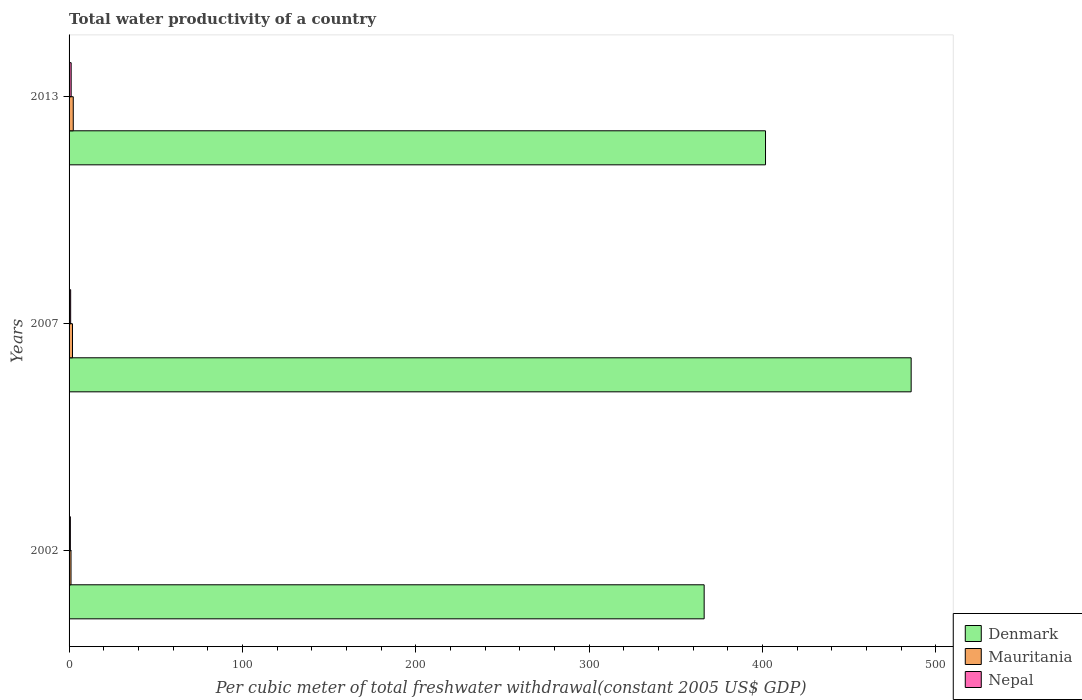How many different coloured bars are there?
Keep it short and to the point. 3. How many groups of bars are there?
Make the answer very short. 3. Are the number of bars on each tick of the Y-axis equal?
Offer a very short reply. Yes. How many bars are there on the 3rd tick from the bottom?
Your answer should be very brief. 3. What is the label of the 2nd group of bars from the top?
Offer a terse response. 2007. What is the total water productivity in Mauritania in 2007?
Your answer should be very brief. 1.98. Across all years, what is the maximum total water productivity in Mauritania?
Ensure brevity in your answer.  2.42. Across all years, what is the minimum total water productivity in Mauritania?
Keep it short and to the point. 1.12. In which year was the total water productivity in Nepal maximum?
Offer a terse response. 2013. In which year was the total water productivity in Nepal minimum?
Ensure brevity in your answer.  2002. What is the total total water productivity in Nepal in the graph?
Keep it short and to the point. 2.87. What is the difference between the total water productivity in Mauritania in 2002 and that in 2013?
Your answer should be very brief. -1.31. What is the difference between the total water productivity in Denmark in 2013 and the total water productivity in Nepal in 2007?
Keep it short and to the point. 400.81. What is the average total water productivity in Mauritania per year?
Provide a succinct answer. 1.84. In the year 2013, what is the difference between the total water productivity in Denmark and total water productivity in Mauritania?
Provide a short and direct response. 399.3. In how many years, is the total water productivity in Mauritania greater than 100 US$?
Keep it short and to the point. 0. What is the ratio of the total water productivity in Denmark in 2007 to that in 2013?
Your answer should be very brief. 1.21. What is the difference between the highest and the second highest total water productivity in Denmark?
Provide a short and direct response. 84.01. What is the difference between the highest and the lowest total water productivity in Nepal?
Offer a terse response. 0.45. What does the 2nd bar from the top in 2002 represents?
Your answer should be compact. Mauritania. What does the 3rd bar from the bottom in 2007 represents?
Your answer should be very brief. Nepal. Is it the case that in every year, the sum of the total water productivity in Nepal and total water productivity in Denmark is greater than the total water productivity in Mauritania?
Ensure brevity in your answer.  Yes. How many bars are there?
Keep it short and to the point. 9. Are all the bars in the graph horizontal?
Make the answer very short. Yes. How many years are there in the graph?
Offer a very short reply. 3. Are the values on the major ticks of X-axis written in scientific E-notation?
Offer a very short reply. No. Does the graph contain grids?
Your answer should be very brief. No. Where does the legend appear in the graph?
Give a very brief answer. Bottom right. How many legend labels are there?
Make the answer very short. 3. How are the legend labels stacked?
Keep it short and to the point. Vertical. What is the title of the graph?
Your answer should be very brief. Total water productivity of a country. What is the label or title of the X-axis?
Make the answer very short. Per cubic meter of total freshwater withdrawal(constant 2005 US$ GDP). What is the Per cubic meter of total freshwater withdrawal(constant 2005 US$ GDP) in Denmark in 2002?
Your answer should be very brief. 366.34. What is the Per cubic meter of total freshwater withdrawal(constant 2005 US$ GDP) in Mauritania in 2002?
Provide a succinct answer. 1.12. What is the Per cubic meter of total freshwater withdrawal(constant 2005 US$ GDP) in Nepal in 2002?
Offer a terse response. 0.76. What is the Per cubic meter of total freshwater withdrawal(constant 2005 US$ GDP) in Denmark in 2007?
Ensure brevity in your answer.  485.73. What is the Per cubic meter of total freshwater withdrawal(constant 2005 US$ GDP) in Mauritania in 2007?
Provide a succinct answer. 1.98. What is the Per cubic meter of total freshwater withdrawal(constant 2005 US$ GDP) of Nepal in 2007?
Provide a succinct answer. 0.92. What is the Per cubic meter of total freshwater withdrawal(constant 2005 US$ GDP) in Denmark in 2013?
Offer a very short reply. 401.72. What is the Per cubic meter of total freshwater withdrawal(constant 2005 US$ GDP) of Mauritania in 2013?
Keep it short and to the point. 2.42. What is the Per cubic meter of total freshwater withdrawal(constant 2005 US$ GDP) of Nepal in 2013?
Keep it short and to the point. 1.2. Across all years, what is the maximum Per cubic meter of total freshwater withdrawal(constant 2005 US$ GDP) in Denmark?
Provide a short and direct response. 485.73. Across all years, what is the maximum Per cubic meter of total freshwater withdrawal(constant 2005 US$ GDP) of Mauritania?
Offer a terse response. 2.42. Across all years, what is the maximum Per cubic meter of total freshwater withdrawal(constant 2005 US$ GDP) in Nepal?
Offer a terse response. 1.2. Across all years, what is the minimum Per cubic meter of total freshwater withdrawal(constant 2005 US$ GDP) in Denmark?
Give a very brief answer. 366.34. Across all years, what is the minimum Per cubic meter of total freshwater withdrawal(constant 2005 US$ GDP) in Mauritania?
Provide a succinct answer. 1.12. Across all years, what is the minimum Per cubic meter of total freshwater withdrawal(constant 2005 US$ GDP) in Nepal?
Ensure brevity in your answer.  0.76. What is the total Per cubic meter of total freshwater withdrawal(constant 2005 US$ GDP) of Denmark in the graph?
Ensure brevity in your answer.  1253.79. What is the total Per cubic meter of total freshwater withdrawal(constant 2005 US$ GDP) in Mauritania in the graph?
Your answer should be compact. 5.52. What is the total Per cubic meter of total freshwater withdrawal(constant 2005 US$ GDP) in Nepal in the graph?
Your response must be concise. 2.87. What is the difference between the Per cubic meter of total freshwater withdrawal(constant 2005 US$ GDP) of Denmark in 2002 and that in 2007?
Make the answer very short. -119.4. What is the difference between the Per cubic meter of total freshwater withdrawal(constant 2005 US$ GDP) in Mauritania in 2002 and that in 2007?
Your answer should be very brief. -0.86. What is the difference between the Per cubic meter of total freshwater withdrawal(constant 2005 US$ GDP) of Nepal in 2002 and that in 2007?
Ensure brevity in your answer.  -0.16. What is the difference between the Per cubic meter of total freshwater withdrawal(constant 2005 US$ GDP) in Denmark in 2002 and that in 2013?
Ensure brevity in your answer.  -35.39. What is the difference between the Per cubic meter of total freshwater withdrawal(constant 2005 US$ GDP) of Mauritania in 2002 and that in 2013?
Keep it short and to the point. -1.31. What is the difference between the Per cubic meter of total freshwater withdrawal(constant 2005 US$ GDP) of Nepal in 2002 and that in 2013?
Offer a very short reply. -0.45. What is the difference between the Per cubic meter of total freshwater withdrawal(constant 2005 US$ GDP) in Denmark in 2007 and that in 2013?
Make the answer very short. 84.01. What is the difference between the Per cubic meter of total freshwater withdrawal(constant 2005 US$ GDP) of Mauritania in 2007 and that in 2013?
Offer a terse response. -0.45. What is the difference between the Per cubic meter of total freshwater withdrawal(constant 2005 US$ GDP) of Nepal in 2007 and that in 2013?
Your answer should be compact. -0.29. What is the difference between the Per cubic meter of total freshwater withdrawal(constant 2005 US$ GDP) of Denmark in 2002 and the Per cubic meter of total freshwater withdrawal(constant 2005 US$ GDP) of Mauritania in 2007?
Provide a succinct answer. 364.36. What is the difference between the Per cubic meter of total freshwater withdrawal(constant 2005 US$ GDP) of Denmark in 2002 and the Per cubic meter of total freshwater withdrawal(constant 2005 US$ GDP) of Nepal in 2007?
Keep it short and to the point. 365.42. What is the difference between the Per cubic meter of total freshwater withdrawal(constant 2005 US$ GDP) of Mauritania in 2002 and the Per cubic meter of total freshwater withdrawal(constant 2005 US$ GDP) of Nepal in 2007?
Offer a terse response. 0.2. What is the difference between the Per cubic meter of total freshwater withdrawal(constant 2005 US$ GDP) in Denmark in 2002 and the Per cubic meter of total freshwater withdrawal(constant 2005 US$ GDP) in Mauritania in 2013?
Ensure brevity in your answer.  363.91. What is the difference between the Per cubic meter of total freshwater withdrawal(constant 2005 US$ GDP) of Denmark in 2002 and the Per cubic meter of total freshwater withdrawal(constant 2005 US$ GDP) of Nepal in 2013?
Your answer should be compact. 365.14. What is the difference between the Per cubic meter of total freshwater withdrawal(constant 2005 US$ GDP) of Mauritania in 2002 and the Per cubic meter of total freshwater withdrawal(constant 2005 US$ GDP) of Nepal in 2013?
Keep it short and to the point. -0.08. What is the difference between the Per cubic meter of total freshwater withdrawal(constant 2005 US$ GDP) of Denmark in 2007 and the Per cubic meter of total freshwater withdrawal(constant 2005 US$ GDP) of Mauritania in 2013?
Your answer should be compact. 483.31. What is the difference between the Per cubic meter of total freshwater withdrawal(constant 2005 US$ GDP) in Denmark in 2007 and the Per cubic meter of total freshwater withdrawal(constant 2005 US$ GDP) in Nepal in 2013?
Ensure brevity in your answer.  484.53. What is the difference between the Per cubic meter of total freshwater withdrawal(constant 2005 US$ GDP) of Mauritania in 2007 and the Per cubic meter of total freshwater withdrawal(constant 2005 US$ GDP) of Nepal in 2013?
Your answer should be very brief. 0.78. What is the average Per cubic meter of total freshwater withdrawal(constant 2005 US$ GDP) in Denmark per year?
Provide a short and direct response. 417.93. What is the average Per cubic meter of total freshwater withdrawal(constant 2005 US$ GDP) of Mauritania per year?
Make the answer very short. 1.84. What is the average Per cubic meter of total freshwater withdrawal(constant 2005 US$ GDP) of Nepal per year?
Your response must be concise. 0.96. In the year 2002, what is the difference between the Per cubic meter of total freshwater withdrawal(constant 2005 US$ GDP) of Denmark and Per cubic meter of total freshwater withdrawal(constant 2005 US$ GDP) of Mauritania?
Ensure brevity in your answer.  365.22. In the year 2002, what is the difference between the Per cubic meter of total freshwater withdrawal(constant 2005 US$ GDP) in Denmark and Per cubic meter of total freshwater withdrawal(constant 2005 US$ GDP) in Nepal?
Offer a terse response. 365.58. In the year 2002, what is the difference between the Per cubic meter of total freshwater withdrawal(constant 2005 US$ GDP) of Mauritania and Per cubic meter of total freshwater withdrawal(constant 2005 US$ GDP) of Nepal?
Provide a short and direct response. 0.36. In the year 2007, what is the difference between the Per cubic meter of total freshwater withdrawal(constant 2005 US$ GDP) in Denmark and Per cubic meter of total freshwater withdrawal(constant 2005 US$ GDP) in Mauritania?
Your answer should be compact. 483.76. In the year 2007, what is the difference between the Per cubic meter of total freshwater withdrawal(constant 2005 US$ GDP) in Denmark and Per cubic meter of total freshwater withdrawal(constant 2005 US$ GDP) in Nepal?
Keep it short and to the point. 484.82. In the year 2013, what is the difference between the Per cubic meter of total freshwater withdrawal(constant 2005 US$ GDP) of Denmark and Per cubic meter of total freshwater withdrawal(constant 2005 US$ GDP) of Mauritania?
Keep it short and to the point. 399.3. In the year 2013, what is the difference between the Per cubic meter of total freshwater withdrawal(constant 2005 US$ GDP) in Denmark and Per cubic meter of total freshwater withdrawal(constant 2005 US$ GDP) in Nepal?
Offer a very short reply. 400.52. In the year 2013, what is the difference between the Per cubic meter of total freshwater withdrawal(constant 2005 US$ GDP) of Mauritania and Per cubic meter of total freshwater withdrawal(constant 2005 US$ GDP) of Nepal?
Give a very brief answer. 1.22. What is the ratio of the Per cubic meter of total freshwater withdrawal(constant 2005 US$ GDP) in Denmark in 2002 to that in 2007?
Offer a very short reply. 0.75. What is the ratio of the Per cubic meter of total freshwater withdrawal(constant 2005 US$ GDP) of Mauritania in 2002 to that in 2007?
Provide a succinct answer. 0.56. What is the ratio of the Per cubic meter of total freshwater withdrawal(constant 2005 US$ GDP) in Nepal in 2002 to that in 2007?
Keep it short and to the point. 0.83. What is the ratio of the Per cubic meter of total freshwater withdrawal(constant 2005 US$ GDP) of Denmark in 2002 to that in 2013?
Your response must be concise. 0.91. What is the ratio of the Per cubic meter of total freshwater withdrawal(constant 2005 US$ GDP) in Mauritania in 2002 to that in 2013?
Offer a terse response. 0.46. What is the ratio of the Per cubic meter of total freshwater withdrawal(constant 2005 US$ GDP) of Nepal in 2002 to that in 2013?
Offer a very short reply. 0.63. What is the ratio of the Per cubic meter of total freshwater withdrawal(constant 2005 US$ GDP) of Denmark in 2007 to that in 2013?
Keep it short and to the point. 1.21. What is the ratio of the Per cubic meter of total freshwater withdrawal(constant 2005 US$ GDP) in Mauritania in 2007 to that in 2013?
Offer a very short reply. 0.82. What is the ratio of the Per cubic meter of total freshwater withdrawal(constant 2005 US$ GDP) of Nepal in 2007 to that in 2013?
Your answer should be very brief. 0.76. What is the difference between the highest and the second highest Per cubic meter of total freshwater withdrawal(constant 2005 US$ GDP) of Denmark?
Your answer should be compact. 84.01. What is the difference between the highest and the second highest Per cubic meter of total freshwater withdrawal(constant 2005 US$ GDP) in Mauritania?
Your response must be concise. 0.45. What is the difference between the highest and the second highest Per cubic meter of total freshwater withdrawal(constant 2005 US$ GDP) of Nepal?
Keep it short and to the point. 0.29. What is the difference between the highest and the lowest Per cubic meter of total freshwater withdrawal(constant 2005 US$ GDP) in Denmark?
Your answer should be very brief. 119.4. What is the difference between the highest and the lowest Per cubic meter of total freshwater withdrawal(constant 2005 US$ GDP) of Mauritania?
Provide a succinct answer. 1.31. What is the difference between the highest and the lowest Per cubic meter of total freshwater withdrawal(constant 2005 US$ GDP) in Nepal?
Offer a terse response. 0.45. 